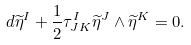Convert formula to latex. <formula><loc_0><loc_0><loc_500><loc_500>d \widetilde { \eta } ^ { I } + \frac { 1 } { 2 } \tau _ { J K } ^ { I } \widetilde { \eta } ^ { J } \wedge \widetilde { \eta } ^ { K } = 0 .</formula> 